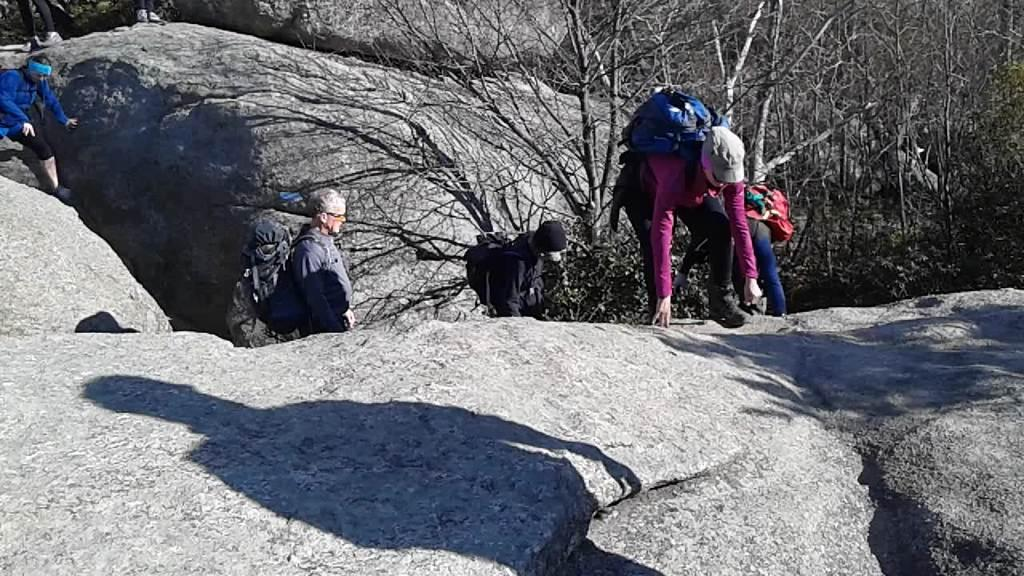Who or what is present in the image? There are people in the image. What are the people wearing? The people are wearing bags. What type of natural elements can be seen in the image? There are rocks and trees visible in the image. What type of flower is growing on the people's heads in the image? There are no flowers visible on the people's heads in the image. 